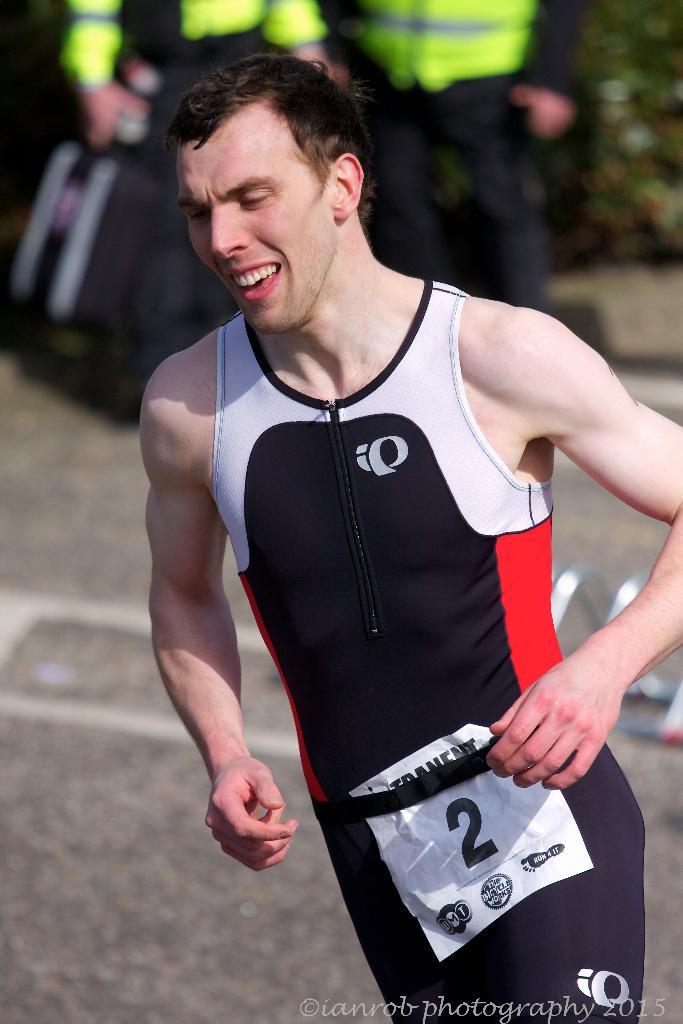What number is this runner?
Offer a terse response. 2. 